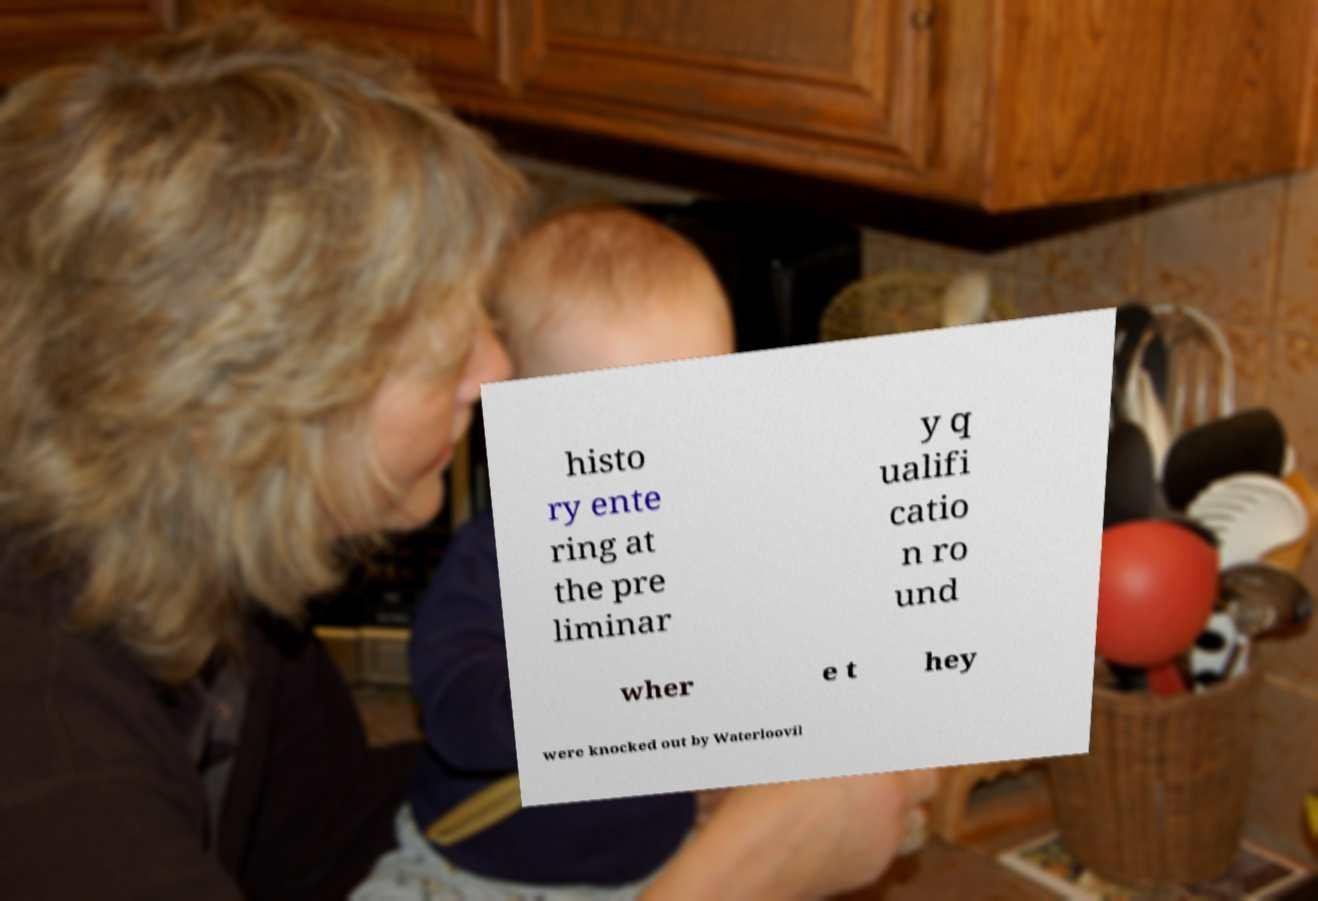For documentation purposes, I need the text within this image transcribed. Could you provide that? histo ry ente ring at the pre liminar y q ualifi catio n ro und wher e t hey were knocked out by Waterloovil 